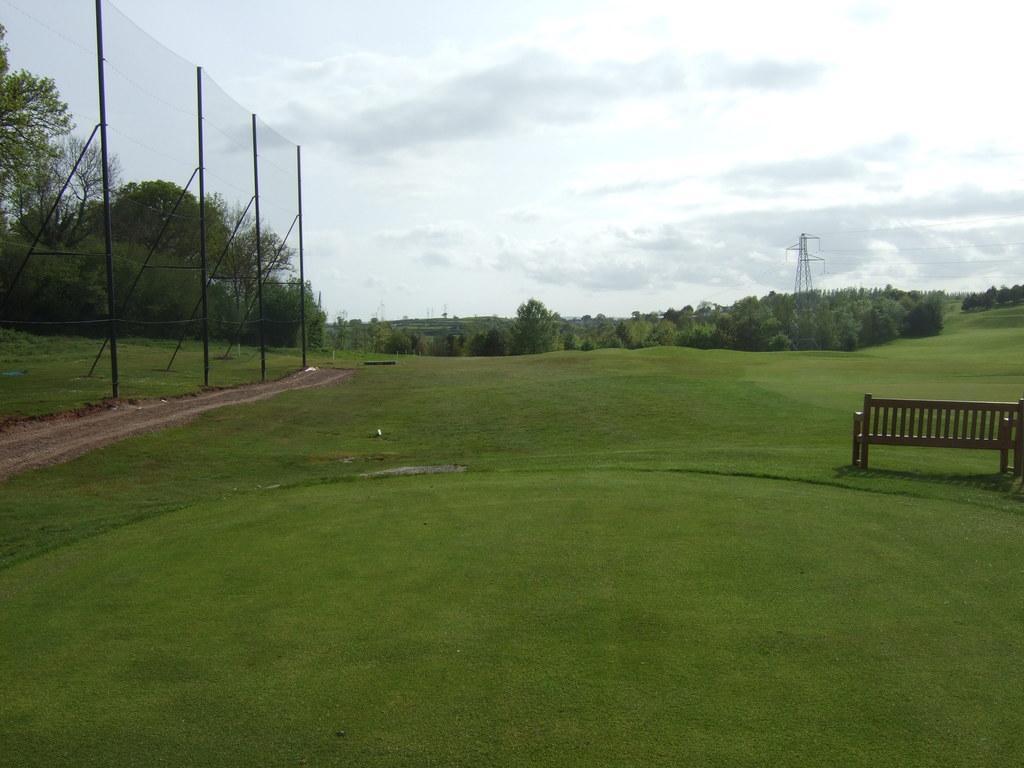Could you give a brief overview of what you see in this image? In this picture I can see a bench on the grass, there is fence, there is a cell tower, there are trees, and in the background there is sky. 